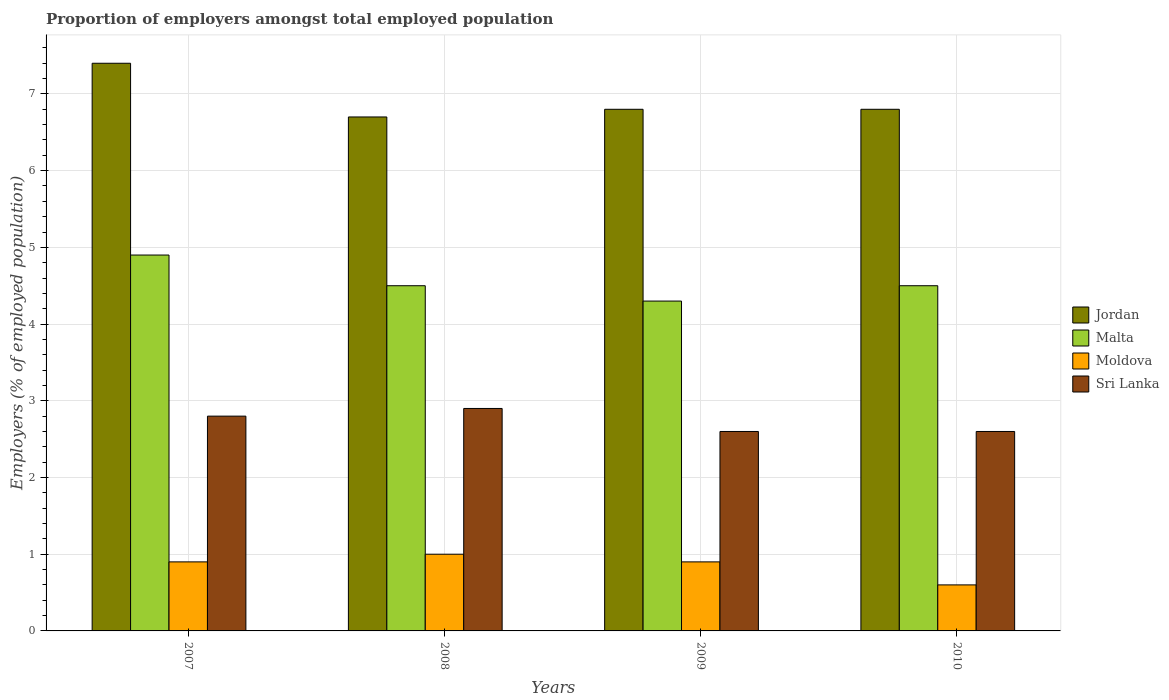How many different coloured bars are there?
Provide a short and direct response. 4. Are the number of bars on each tick of the X-axis equal?
Give a very brief answer. Yes. How many bars are there on the 2nd tick from the right?
Your response must be concise. 4. What is the proportion of employers in Malta in 2010?
Offer a very short reply. 4.5. Across all years, what is the maximum proportion of employers in Jordan?
Offer a terse response. 7.4. Across all years, what is the minimum proportion of employers in Sri Lanka?
Your answer should be compact. 2.6. In which year was the proportion of employers in Sri Lanka maximum?
Offer a very short reply. 2008. In which year was the proportion of employers in Malta minimum?
Make the answer very short. 2009. What is the total proportion of employers in Jordan in the graph?
Offer a terse response. 27.7. What is the difference between the proportion of employers in Moldova in 2008 and that in 2009?
Provide a short and direct response. 0.1. What is the difference between the proportion of employers in Sri Lanka in 2007 and the proportion of employers in Malta in 2009?
Your response must be concise. -1.5. What is the average proportion of employers in Moldova per year?
Offer a terse response. 0.85. In the year 2009, what is the difference between the proportion of employers in Moldova and proportion of employers in Malta?
Offer a very short reply. -3.4. In how many years, is the proportion of employers in Malta greater than 1.4 %?
Provide a short and direct response. 4. What is the ratio of the proportion of employers in Jordan in 2008 to that in 2010?
Give a very brief answer. 0.99. Is the proportion of employers in Malta in 2008 less than that in 2010?
Offer a terse response. No. What is the difference between the highest and the second highest proportion of employers in Jordan?
Provide a succinct answer. 0.6. What is the difference between the highest and the lowest proportion of employers in Jordan?
Your answer should be very brief. 0.7. In how many years, is the proportion of employers in Moldova greater than the average proportion of employers in Moldova taken over all years?
Ensure brevity in your answer.  3. Is the sum of the proportion of employers in Sri Lanka in 2007 and 2009 greater than the maximum proportion of employers in Malta across all years?
Provide a succinct answer. Yes. Is it the case that in every year, the sum of the proportion of employers in Jordan and proportion of employers in Moldova is greater than the sum of proportion of employers in Malta and proportion of employers in Sri Lanka?
Provide a short and direct response. No. What does the 3rd bar from the left in 2007 represents?
Ensure brevity in your answer.  Moldova. What does the 3rd bar from the right in 2009 represents?
Your answer should be compact. Malta. How many bars are there?
Offer a terse response. 16. Are all the bars in the graph horizontal?
Your response must be concise. No. How many years are there in the graph?
Your response must be concise. 4. What is the difference between two consecutive major ticks on the Y-axis?
Ensure brevity in your answer.  1. Does the graph contain any zero values?
Offer a very short reply. No. Does the graph contain grids?
Your answer should be very brief. Yes. Where does the legend appear in the graph?
Provide a succinct answer. Center right. What is the title of the graph?
Your answer should be compact. Proportion of employers amongst total employed population. Does "Bosnia and Herzegovina" appear as one of the legend labels in the graph?
Give a very brief answer. No. What is the label or title of the X-axis?
Offer a terse response. Years. What is the label or title of the Y-axis?
Offer a very short reply. Employers (% of employed population). What is the Employers (% of employed population) in Jordan in 2007?
Your response must be concise. 7.4. What is the Employers (% of employed population) of Malta in 2007?
Your answer should be compact. 4.9. What is the Employers (% of employed population) of Moldova in 2007?
Provide a short and direct response. 0.9. What is the Employers (% of employed population) in Sri Lanka in 2007?
Give a very brief answer. 2.8. What is the Employers (% of employed population) of Jordan in 2008?
Ensure brevity in your answer.  6.7. What is the Employers (% of employed population) in Sri Lanka in 2008?
Ensure brevity in your answer.  2.9. What is the Employers (% of employed population) in Jordan in 2009?
Offer a terse response. 6.8. What is the Employers (% of employed population) of Malta in 2009?
Your answer should be compact. 4.3. What is the Employers (% of employed population) in Moldova in 2009?
Offer a very short reply. 0.9. What is the Employers (% of employed population) in Sri Lanka in 2009?
Give a very brief answer. 2.6. What is the Employers (% of employed population) in Jordan in 2010?
Offer a very short reply. 6.8. What is the Employers (% of employed population) in Moldova in 2010?
Provide a succinct answer. 0.6. What is the Employers (% of employed population) of Sri Lanka in 2010?
Your response must be concise. 2.6. Across all years, what is the maximum Employers (% of employed population) of Jordan?
Offer a terse response. 7.4. Across all years, what is the maximum Employers (% of employed population) in Malta?
Your answer should be compact. 4.9. Across all years, what is the maximum Employers (% of employed population) in Sri Lanka?
Keep it short and to the point. 2.9. Across all years, what is the minimum Employers (% of employed population) in Jordan?
Your response must be concise. 6.7. Across all years, what is the minimum Employers (% of employed population) of Malta?
Provide a short and direct response. 4.3. Across all years, what is the minimum Employers (% of employed population) in Moldova?
Make the answer very short. 0.6. Across all years, what is the minimum Employers (% of employed population) in Sri Lanka?
Your response must be concise. 2.6. What is the total Employers (% of employed population) of Jordan in the graph?
Offer a very short reply. 27.7. What is the difference between the Employers (% of employed population) of Jordan in 2007 and that in 2008?
Provide a succinct answer. 0.7. What is the difference between the Employers (% of employed population) of Sri Lanka in 2007 and that in 2008?
Offer a terse response. -0.1. What is the difference between the Employers (% of employed population) of Malta in 2007 and that in 2009?
Provide a succinct answer. 0.6. What is the difference between the Employers (% of employed population) of Sri Lanka in 2007 and that in 2009?
Give a very brief answer. 0.2. What is the difference between the Employers (% of employed population) of Moldova in 2007 and that in 2010?
Provide a succinct answer. 0.3. What is the difference between the Employers (% of employed population) in Jordan in 2008 and that in 2009?
Offer a terse response. -0.1. What is the difference between the Employers (% of employed population) in Moldova in 2008 and that in 2009?
Your answer should be compact. 0.1. What is the difference between the Employers (% of employed population) in Sri Lanka in 2008 and that in 2009?
Provide a succinct answer. 0.3. What is the difference between the Employers (% of employed population) in Jordan in 2008 and that in 2010?
Give a very brief answer. -0.1. What is the difference between the Employers (% of employed population) of Malta in 2008 and that in 2010?
Your answer should be very brief. 0. What is the difference between the Employers (% of employed population) of Moldova in 2008 and that in 2010?
Keep it short and to the point. 0.4. What is the difference between the Employers (% of employed population) in Jordan in 2009 and that in 2010?
Your answer should be compact. 0. What is the difference between the Employers (% of employed population) in Moldova in 2009 and that in 2010?
Your answer should be compact. 0.3. What is the difference between the Employers (% of employed population) in Jordan in 2007 and the Employers (% of employed population) in Malta in 2008?
Your answer should be compact. 2.9. What is the difference between the Employers (% of employed population) in Jordan in 2007 and the Employers (% of employed population) in Sri Lanka in 2008?
Ensure brevity in your answer.  4.5. What is the difference between the Employers (% of employed population) of Malta in 2007 and the Employers (% of employed population) of Sri Lanka in 2008?
Provide a succinct answer. 2. What is the difference between the Employers (% of employed population) of Malta in 2007 and the Employers (% of employed population) of Moldova in 2009?
Provide a succinct answer. 4. What is the difference between the Employers (% of employed population) of Malta in 2007 and the Employers (% of employed population) of Sri Lanka in 2009?
Ensure brevity in your answer.  2.3. What is the difference between the Employers (% of employed population) of Jordan in 2007 and the Employers (% of employed population) of Sri Lanka in 2010?
Offer a very short reply. 4.8. What is the difference between the Employers (% of employed population) in Malta in 2007 and the Employers (% of employed population) in Moldova in 2010?
Offer a very short reply. 4.3. What is the difference between the Employers (% of employed population) in Jordan in 2008 and the Employers (% of employed population) in Moldova in 2010?
Your answer should be compact. 6.1. What is the difference between the Employers (% of employed population) of Malta in 2008 and the Employers (% of employed population) of Moldova in 2010?
Your answer should be compact. 3.9. What is the difference between the Employers (% of employed population) in Malta in 2008 and the Employers (% of employed population) in Sri Lanka in 2010?
Your response must be concise. 1.9. What is the difference between the Employers (% of employed population) of Moldova in 2008 and the Employers (% of employed population) of Sri Lanka in 2010?
Your answer should be very brief. -1.6. What is the difference between the Employers (% of employed population) in Jordan in 2009 and the Employers (% of employed population) in Malta in 2010?
Offer a very short reply. 2.3. What is the difference between the Employers (% of employed population) of Moldova in 2009 and the Employers (% of employed population) of Sri Lanka in 2010?
Ensure brevity in your answer.  -1.7. What is the average Employers (% of employed population) in Jordan per year?
Your response must be concise. 6.92. What is the average Employers (% of employed population) in Malta per year?
Keep it short and to the point. 4.55. What is the average Employers (% of employed population) of Moldova per year?
Keep it short and to the point. 0.85. What is the average Employers (% of employed population) of Sri Lanka per year?
Your answer should be compact. 2.73. In the year 2007, what is the difference between the Employers (% of employed population) in Jordan and Employers (% of employed population) in Malta?
Give a very brief answer. 2.5. In the year 2007, what is the difference between the Employers (% of employed population) of Jordan and Employers (% of employed population) of Moldova?
Offer a very short reply. 6.5. In the year 2007, what is the difference between the Employers (% of employed population) of Jordan and Employers (% of employed population) of Sri Lanka?
Offer a terse response. 4.6. In the year 2007, what is the difference between the Employers (% of employed population) in Malta and Employers (% of employed population) in Moldova?
Keep it short and to the point. 4. In the year 2007, what is the difference between the Employers (% of employed population) of Moldova and Employers (% of employed population) of Sri Lanka?
Offer a very short reply. -1.9. In the year 2008, what is the difference between the Employers (% of employed population) in Jordan and Employers (% of employed population) in Sri Lanka?
Your response must be concise. 3.8. In the year 2008, what is the difference between the Employers (% of employed population) in Malta and Employers (% of employed population) in Moldova?
Your answer should be compact. 3.5. In the year 2008, what is the difference between the Employers (% of employed population) in Malta and Employers (% of employed population) in Sri Lanka?
Provide a short and direct response. 1.6. In the year 2008, what is the difference between the Employers (% of employed population) of Moldova and Employers (% of employed population) of Sri Lanka?
Offer a very short reply. -1.9. In the year 2009, what is the difference between the Employers (% of employed population) in Jordan and Employers (% of employed population) in Malta?
Provide a short and direct response. 2.5. In the year 2009, what is the difference between the Employers (% of employed population) of Malta and Employers (% of employed population) of Sri Lanka?
Ensure brevity in your answer.  1.7. In the year 2009, what is the difference between the Employers (% of employed population) of Moldova and Employers (% of employed population) of Sri Lanka?
Give a very brief answer. -1.7. In the year 2010, what is the difference between the Employers (% of employed population) of Jordan and Employers (% of employed population) of Sri Lanka?
Give a very brief answer. 4.2. In the year 2010, what is the difference between the Employers (% of employed population) in Malta and Employers (% of employed population) in Moldova?
Offer a terse response. 3.9. In the year 2010, what is the difference between the Employers (% of employed population) of Moldova and Employers (% of employed population) of Sri Lanka?
Provide a succinct answer. -2. What is the ratio of the Employers (% of employed population) in Jordan in 2007 to that in 2008?
Offer a terse response. 1.1. What is the ratio of the Employers (% of employed population) of Malta in 2007 to that in 2008?
Provide a short and direct response. 1.09. What is the ratio of the Employers (% of employed population) of Sri Lanka in 2007 to that in 2008?
Provide a succinct answer. 0.97. What is the ratio of the Employers (% of employed population) in Jordan in 2007 to that in 2009?
Keep it short and to the point. 1.09. What is the ratio of the Employers (% of employed population) in Malta in 2007 to that in 2009?
Ensure brevity in your answer.  1.14. What is the ratio of the Employers (% of employed population) in Sri Lanka in 2007 to that in 2009?
Your answer should be very brief. 1.08. What is the ratio of the Employers (% of employed population) in Jordan in 2007 to that in 2010?
Provide a succinct answer. 1.09. What is the ratio of the Employers (% of employed population) in Malta in 2007 to that in 2010?
Your answer should be compact. 1.09. What is the ratio of the Employers (% of employed population) of Sri Lanka in 2007 to that in 2010?
Give a very brief answer. 1.08. What is the ratio of the Employers (% of employed population) of Malta in 2008 to that in 2009?
Your response must be concise. 1.05. What is the ratio of the Employers (% of employed population) of Moldova in 2008 to that in 2009?
Your answer should be compact. 1.11. What is the ratio of the Employers (% of employed population) of Sri Lanka in 2008 to that in 2009?
Your answer should be very brief. 1.12. What is the ratio of the Employers (% of employed population) of Jordan in 2008 to that in 2010?
Your answer should be compact. 0.99. What is the ratio of the Employers (% of employed population) of Moldova in 2008 to that in 2010?
Your answer should be very brief. 1.67. What is the ratio of the Employers (% of employed population) of Sri Lanka in 2008 to that in 2010?
Provide a succinct answer. 1.12. What is the ratio of the Employers (% of employed population) in Jordan in 2009 to that in 2010?
Offer a very short reply. 1. What is the ratio of the Employers (% of employed population) in Malta in 2009 to that in 2010?
Provide a succinct answer. 0.96. What is the ratio of the Employers (% of employed population) in Moldova in 2009 to that in 2010?
Keep it short and to the point. 1.5. What is the difference between the highest and the second highest Employers (% of employed population) of Jordan?
Your answer should be very brief. 0.6. What is the difference between the highest and the second highest Employers (% of employed population) of Sri Lanka?
Provide a short and direct response. 0.1. What is the difference between the highest and the lowest Employers (% of employed population) of Jordan?
Give a very brief answer. 0.7. What is the difference between the highest and the lowest Employers (% of employed population) of Malta?
Your answer should be very brief. 0.6. What is the difference between the highest and the lowest Employers (% of employed population) of Sri Lanka?
Your response must be concise. 0.3. 